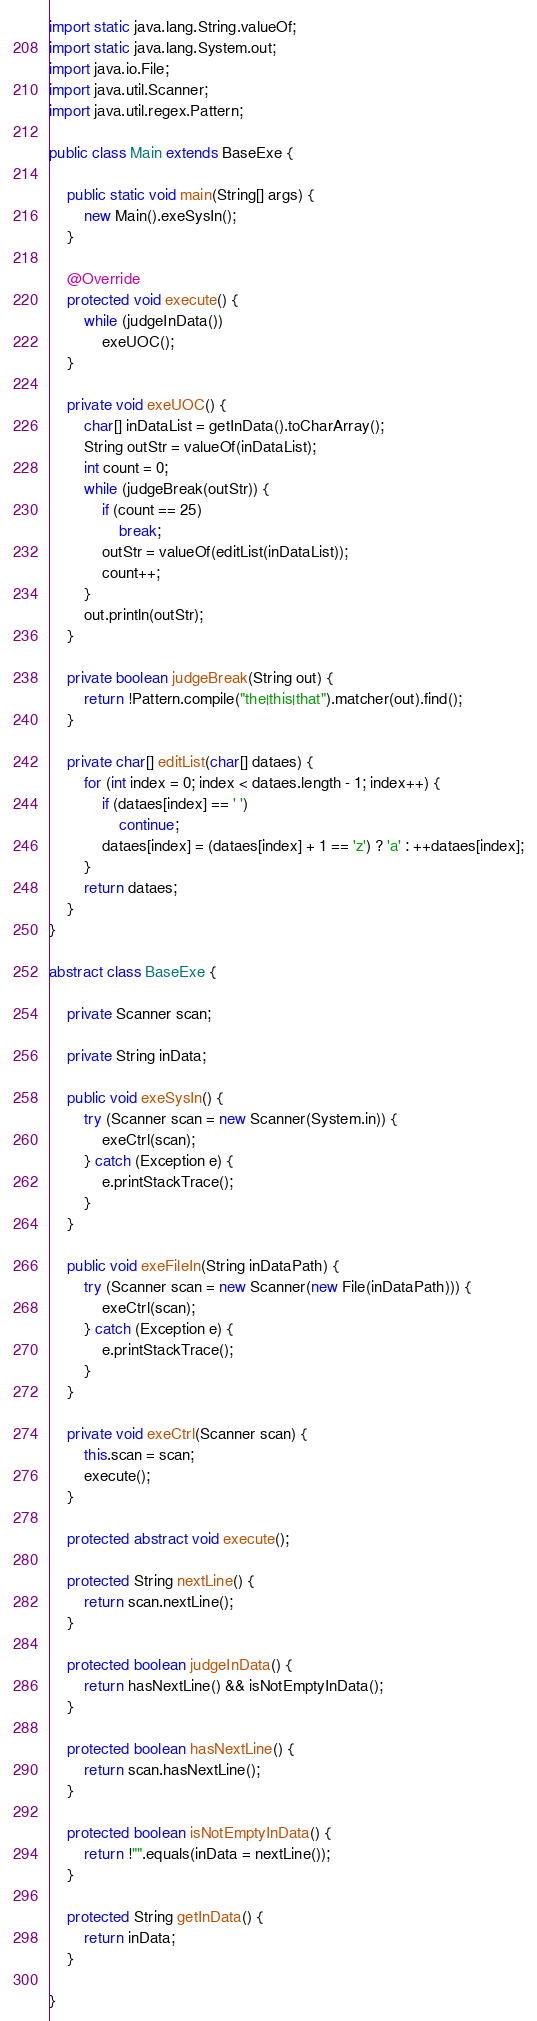Convert code to text. <code><loc_0><loc_0><loc_500><loc_500><_Java_>import static java.lang.String.valueOf;
import static java.lang.System.out;
import java.io.File;
import java.util.Scanner;
import java.util.regex.Pattern;

public class Main extends BaseExe {

    public static void main(String[] args) {
        new Main().exeSysIn();
    }

    @Override
    protected void execute() {
        while (judgeInData())
            exeUOC();
    }

    private void exeUOC() {
        char[] inDataList = getInData().toCharArray();
        String outStr = valueOf(inDataList);
        int count = 0;
        while (judgeBreak(outStr)) {
            if (count == 25)
                break;
            outStr = valueOf(editList(inDataList));
            count++;
        }
        out.println(outStr);
    }

    private boolean judgeBreak(String out) {
        return !Pattern.compile("the|this|that").matcher(out).find();
    }

    private char[] editList(char[] dataes) {
        for (int index = 0; index < dataes.length - 1; index++) {
            if (dataes[index] == ' ')
                continue;
            dataes[index] = (dataes[index] + 1 == 'z') ? 'a' : ++dataes[index];
        }
        return dataes;
    }
}

abstract class BaseExe {

    private Scanner scan;

    private String inData;

    public void exeSysIn() {
        try (Scanner scan = new Scanner(System.in)) {
            exeCtrl(scan);
        } catch (Exception e) {
            e.printStackTrace();
        }
    }

    public void exeFileIn(String inDataPath) {
        try (Scanner scan = new Scanner(new File(inDataPath))) {
            exeCtrl(scan);
        } catch (Exception e) {
            e.printStackTrace();
        }
    }

    private void exeCtrl(Scanner scan) {
        this.scan = scan;
        execute();
    }

    protected abstract void execute();

    protected String nextLine() {
        return scan.nextLine();
    }

    protected boolean judgeInData() {
        return hasNextLine() && isNotEmptyInData();
    }

    protected boolean hasNextLine() {
        return scan.hasNextLine();
    }

    protected boolean isNotEmptyInData() {
        return !"".equals(inData = nextLine());
    }

    protected String getInData() {
        return inData;
    }

}</code> 